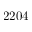<formula> <loc_0><loc_0><loc_500><loc_500>2 2 0 4</formula> 